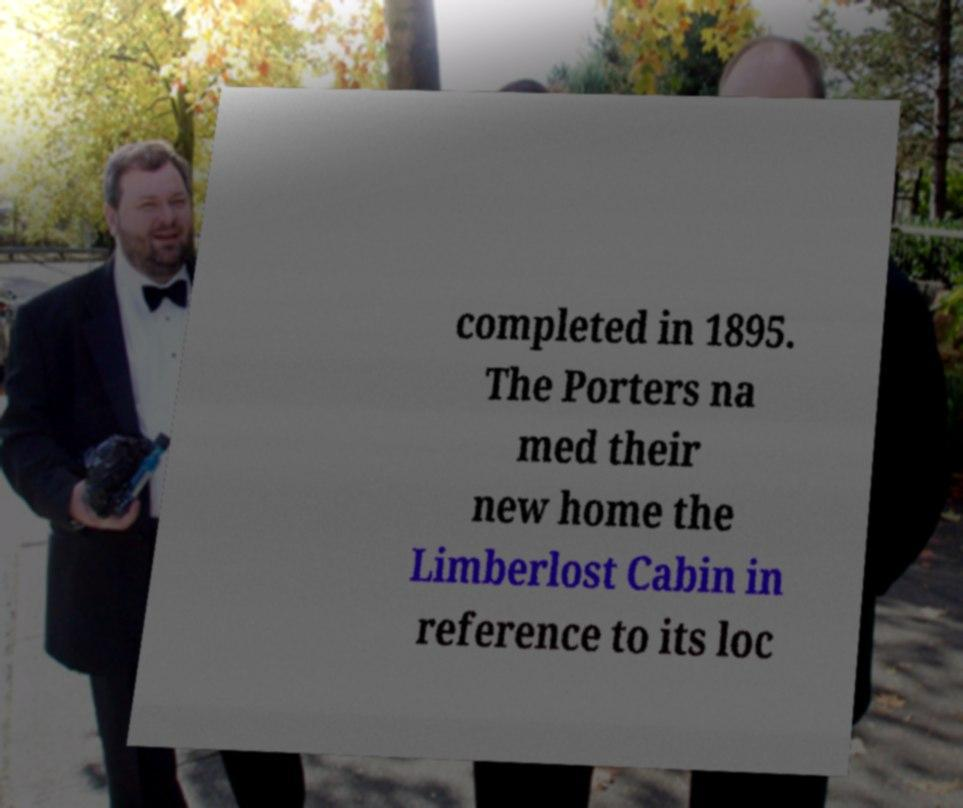What messages or text are displayed in this image? I need them in a readable, typed format. completed in 1895. The Porters na med their new home the Limberlost Cabin in reference to its loc 